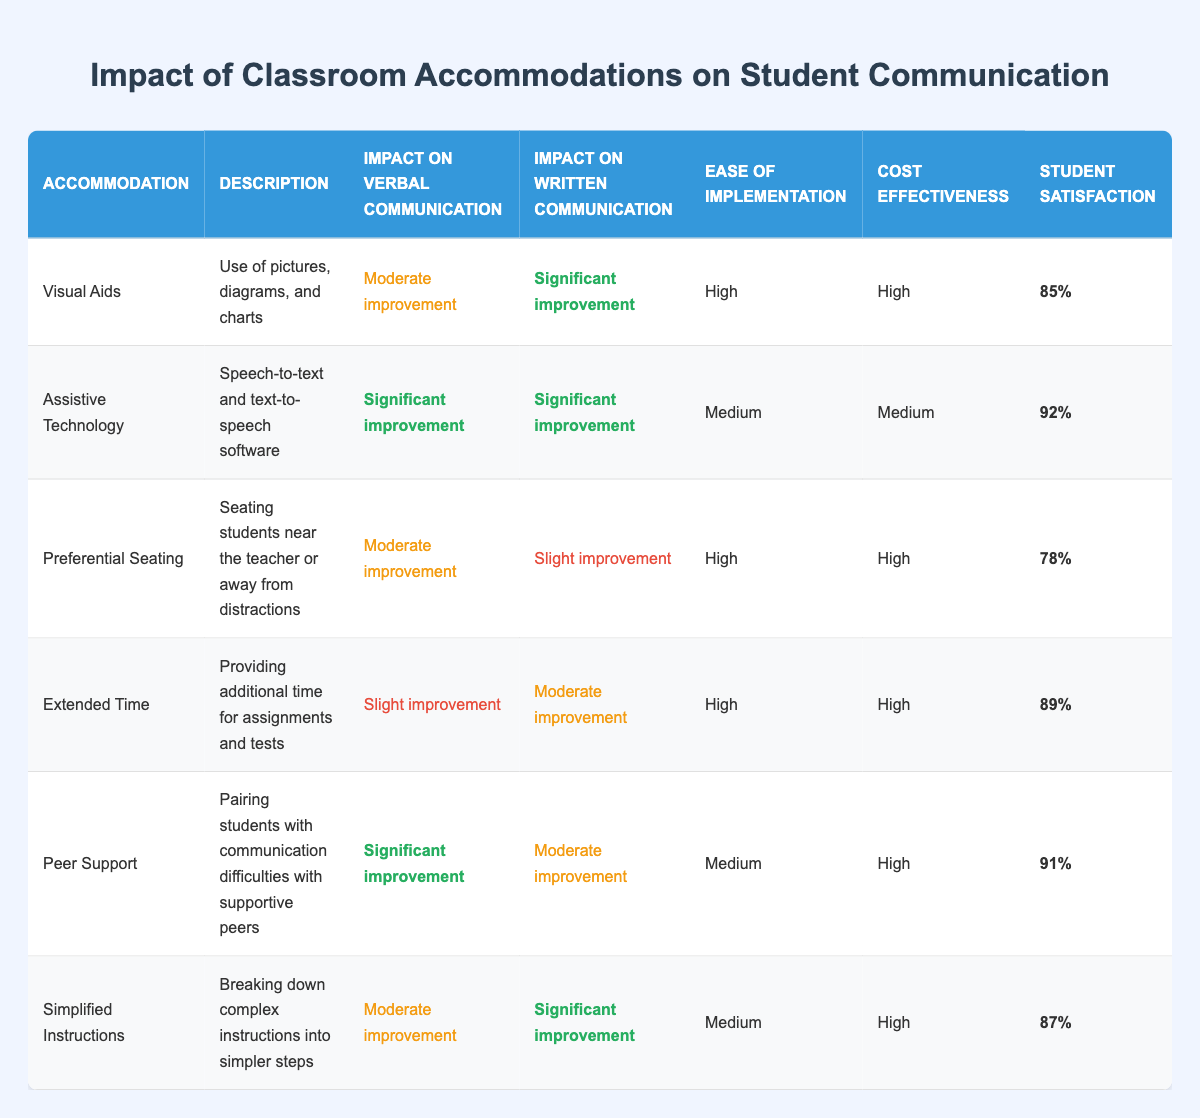What is the impact on verbal communication for Visual Aids? The table shows that Visual Aids have a "Moderate improvement" in verbal communication.
Answer: Moderate improvement Which accommodation has the highest student satisfaction? By examining the table, Assistive Technology has the highest student satisfaction at 92%.
Answer: 92% What is the difference in impact on written communication between Peer Support and Extended Time? Peer Support has a "Moderate improvement" in written communication while Extended Time has a "Moderate improvement." There is no difference in their impact level.
Answer: No difference Is the ease of implementation for Simplified Instructions high? The table indicates that the ease of implementation for Simplified Instructions is categorized as "Medium." Therefore, it is not high.
Answer: No What is the average student satisfaction for all accommodations listed? The student satisfaction percentages are 85%, 92%, 78%, 89%, 91%, and 87%. To find the average, sum these values (85 + 92 + 78 + 89 + 91 + 87 = 522) and divide by the number of accommodations (522/6 = 87).
Answer: 87 Which accommodation(s) have significant improvement in both verbal and written communication? The table lists Assistive Technology as having "Significant improvement" in verbal and written communication. Therefore, it is the only one that satisfies this criterion.
Answer: Assistive Technology For which accommodation is the impact on verbal communication slightly improved? The table specifies that Extended Time has a "Slight improvement" for verbal communication.
Answer: Extended Time How many accommodations have a high cost-effectiveness rating? In the table, Visual Aids, Preferential Seating, Peer Support, and Simplified Instructions are all marked with "High" for cost-effectiveness, totaling four accommodations.
Answer: Four 